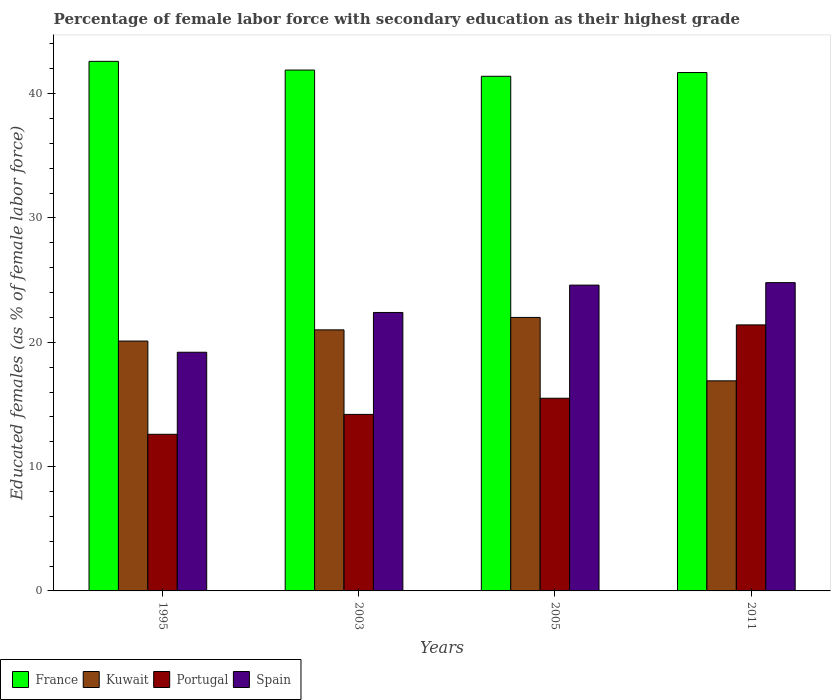How many different coloured bars are there?
Your answer should be very brief. 4. How many groups of bars are there?
Your answer should be compact. 4. What is the percentage of female labor force with secondary education in Spain in 2003?
Your answer should be compact. 22.4. Across all years, what is the maximum percentage of female labor force with secondary education in Kuwait?
Offer a very short reply. 22. Across all years, what is the minimum percentage of female labor force with secondary education in Portugal?
Your answer should be compact. 12.6. In which year was the percentage of female labor force with secondary education in Spain minimum?
Keep it short and to the point. 1995. What is the total percentage of female labor force with secondary education in Spain in the graph?
Keep it short and to the point. 91. What is the difference between the percentage of female labor force with secondary education in Portugal in 1995 and that in 2003?
Keep it short and to the point. -1.6. What is the difference between the percentage of female labor force with secondary education in France in 2011 and the percentage of female labor force with secondary education in Kuwait in 2003?
Make the answer very short. 20.7. In the year 2005, what is the difference between the percentage of female labor force with secondary education in Kuwait and percentage of female labor force with secondary education in Portugal?
Give a very brief answer. 6.5. What is the ratio of the percentage of female labor force with secondary education in Portugal in 1995 to that in 2003?
Offer a very short reply. 0.89. Is the percentage of female labor force with secondary education in Portugal in 2003 less than that in 2005?
Give a very brief answer. Yes. What is the difference between the highest and the lowest percentage of female labor force with secondary education in Kuwait?
Your answer should be very brief. 5.1. Is the sum of the percentage of female labor force with secondary education in France in 1995 and 2003 greater than the maximum percentage of female labor force with secondary education in Spain across all years?
Make the answer very short. Yes. What does the 2nd bar from the left in 2003 represents?
Your answer should be compact. Kuwait. What does the 1st bar from the right in 2003 represents?
Give a very brief answer. Spain. Is it the case that in every year, the sum of the percentage of female labor force with secondary education in Kuwait and percentage of female labor force with secondary education in France is greater than the percentage of female labor force with secondary education in Portugal?
Provide a succinct answer. Yes. Are all the bars in the graph horizontal?
Your response must be concise. No. How many years are there in the graph?
Give a very brief answer. 4. Does the graph contain any zero values?
Provide a succinct answer. No. Does the graph contain grids?
Keep it short and to the point. No. How many legend labels are there?
Ensure brevity in your answer.  4. What is the title of the graph?
Your answer should be very brief. Percentage of female labor force with secondary education as their highest grade. What is the label or title of the Y-axis?
Offer a terse response. Educated females (as % of female labor force). What is the Educated females (as % of female labor force) of France in 1995?
Provide a succinct answer. 42.6. What is the Educated females (as % of female labor force) of Kuwait in 1995?
Provide a short and direct response. 20.1. What is the Educated females (as % of female labor force) in Portugal in 1995?
Keep it short and to the point. 12.6. What is the Educated females (as % of female labor force) in Spain in 1995?
Your answer should be very brief. 19.2. What is the Educated females (as % of female labor force) of France in 2003?
Your response must be concise. 41.9. What is the Educated females (as % of female labor force) in Portugal in 2003?
Keep it short and to the point. 14.2. What is the Educated females (as % of female labor force) in Spain in 2003?
Provide a short and direct response. 22.4. What is the Educated females (as % of female labor force) of France in 2005?
Provide a succinct answer. 41.4. What is the Educated females (as % of female labor force) of Kuwait in 2005?
Make the answer very short. 22. What is the Educated females (as % of female labor force) of Spain in 2005?
Give a very brief answer. 24.6. What is the Educated females (as % of female labor force) in France in 2011?
Offer a terse response. 41.7. What is the Educated females (as % of female labor force) of Kuwait in 2011?
Provide a short and direct response. 16.9. What is the Educated females (as % of female labor force) in Portugal in 2011?
Your answer should be compact. 21.4. What is the Educated females (as % of female labor force) of Spain in 2011?
Your answer should be compact. 24.8. Across all years, what is the maximum Educated females (as % of female labor force) in France?
Make the answer very short. 42.6. Across all years, what is the maximum Educated females (as % of female labor force) in Portugal?
Your answer should be very brief. 21.4. Across all years, what is the maximum Educated females (as % of female labor force) in Spain?
Your answer should be compact. 24.8. Across all years, what is the minimum Educated females (as % of female labor force) of France?
Your answer should be very brief. 41.4. Across all years, what is the minimum Educated females (as % of female labor force) in Kuwait?
Provide a succinct answer. 16.9. Across all years, what is the minimum Educated females (as % of female labor force) in Portugal?
Offer a very short reply. 12.6. Across all years, what is the minimum Educated females (as % of female labor force) in Spain?
Your answer should be very brief. 19.2. What is the total Educated females (as % of female labor force) in France in the graph?
Your response must be concise. 167.6. What is the total Educated females (as % of female labor force) of Kuwait in the graph?
Your response must be concise. 80. What is the total Educated females (as % of female labor force) in Portugal in the graph?
Offer a very short reply. 63.7. What is the total Educated females (as % of female labor force) in Spain in the graph?
Your response must be concise. 91. What is the difference between the Educated females (as % of female labor force) in Kuwait in 1995 and that in 2003?
Your response must be concise. -0.9. What is the difference between the Educated females (as % of female labor force) in Kuwait in 1995 and that in 2011?
Your answer should be compact. 3.2. What is the difference between the Educated females (as % of female labor force) of Portugal in 1995 and that in 2011?
Offer a terse response. -8.8. What is the difference between the Educated females (as % of female labor force) in Portugal in 2003 and that in 2005?
Give a very brief answer. -1.3. What is the difference between the Educated females (as % of female labor force) of France in 2003 and that in 2011?
Provide a short and direct response. 0.2. What is the difference between the Educated females (as % of female labor force) in Portugal in 2003 and that in 2011?
Give a very brief answer. -7.2. What is the difference between the Educated females (as % of female labor force) of Kuwait in 2005 and that in 2011?
Provide a short and direct response. 5.1. What is the difference between the Educated females (as % of female labor force) of Portugal in 2005 and that in 2011?
Ensure brevity in your answer.  -5.9. What is the difference between the Educated females (as % of female labor force) of Spain in 2005 and that in 2011?
Your answer should be compact. -0.2. What is the difference between the Educated females (as % of female labor force) of France in 1995 and the Educated females (as % of female labor force) of Kuwait in 2003?
Provide a succinct answer. 21.6. What is the difference between the Educated females (as % of female labor force) in France in 1995 and the Educated females (as % of female labor force) in Portugal in 2003?
Your answer should be compact. 28.4. What is the difference between the Educated females (as % of female labor force) in France in 1995 and the Educated females (as % of female labor force) in Spain in 2003?
Ensure brevity in your answer.  20.2. What is the difference between the Educated females (as % of female labor force) in Kuwait in 1995 and the Educated females (as % of female labor force) in Spain in 2003?
Keep it short and to the point. -2.3. What is the difference between the Educated females (as % of female labor force) in France in 1995 and the Educated females (as % of female labor force) in Kuwait in 2005?
Provide a succinct answer. 20.6. What is the difference between the Educated females (as % of female labor force) in France in 1995 and the Educated females (as % of female labor force) in Portugal in 2005?
Keep it short and to the point. 27.1. What is the difference between the Educated females (as % of female labor force) of Kuwait in 1995 and the Educated females (as % of female labor force) of Portugal in 2005?
Offer a terse response. 4.6. What is the difference between the Educated females (as % of female labor force) of Portugal in 1995 and the Educated females (as % of female labor force) of Spain in 2005?
Offer a very short reply. -12. What is the difference between the Educated females (as % of female labor force) of France in 1995 and the Educated females (as % of female labor force) of Kuwait in 2011?
Offer a terse response. 25.7. What is the difference between the Educated females (as % of female labor force) in France in 1995 and the Educated females (as % of female labor force) in Portugal in 2011?
Provide a succinct answer. 21.2. What is the difference between the Educated females (as % of female labor force) in Kuwait in 1995 and the Educated females (as % of female labor force) in Portugal in 2011?
Your answer should be compact. -1.3. What is the difference between the Educated females (as % of female labor force) in Kuwait in 1995 and the Educated females (as % of female labor force) in Spain in 2011?
Give a very brief answer. -4.7. What is the difference between the Educated females (as % of female labor force) of Portugal in 1995 and the Educated females (as % of female labor force) of Spain in 2011?
Provide a short and direct response. -12.2. What is the difference between the Educated females (as % of female labor force) in France in 2003 and the Educated females (as % of female labor force) in Kuwait in 2005?
Your answer should be very brief. 19.9. What is the difference between the Educated females (as % of female labor force) in France in 2003 and the Educated females (as % of female labor force) in Portugal in 2005?
Keep it short and to the point. 26.4. What is the difference between the Educated females (as % of female labor force) of France in 2003 and the Educated females (as % of female labor force) of Spain in 2005?
Your response must be concise. 17.3. What is the difference between the Educated females (as % of female labor force) in Kuwait in 2003 and the Educated females (as % of female labor force) in Portugal in 2005?
Your response must be concise. 5.5. What is the difference between the Educated females (as % of female labor force) of Kuwait in 2003 and the Educated females (as % of female labor force) of Spain in 2005?
Your response must be concise. -3.6. What is the difference between the Educated females (as % of female labor force) of France in 2003 and the Educated females (as % of female labor force) of Kuwait in 2011?
Your answer should be very brief. 25. What is the difference between the Educated females (as % of female labor force) of France in 2003 and the Educated females (as % of female labor force) of Portugal in 2011?
Provide a short and direct response. 20.5. What is the difference between the Educated females (as % of female labor force) of Portugal in 2003 and the Educated females (as % of female labor force) of Spain in 2011?
Your answer should be compact. -10.6. What is the difference between the Educated females (as % of female labor force) in France in 2005 and the Educated females (as % of female labor force) in Kuwait in 2011?
Provide a succinct answer. 24.5. What is the difference between the Educated females (as % of female labor force) of France in 2005 and the Educated females (as % of female labor force) of Portugal in 2011?
Make the answer very short. 20. What is the difference between the Educated females (as % of female labor force) in Kuwait in 2005 and the Educated females (as % of female labor force) in Portugal in 2011?
Give a very brief answer. 0.6. What is the difference between the Educated females (as % of female labor force) of Kuwait in 2005 and the Educated females (as % of female labor force) of Spain in 2011?
Make the answer very short. -2.8. What is the average Educated females (as % of female labor force) in France per year?
Offer a terse response. 41.9. What is the average Educated females (as % of female labor force) of Portugal per year?
Provide a short and direct response. 15.93. What is the average Educated females (as % of female labor force) in Spain per year?
Offer a terse response. 22.75. In the year 1995, what is the difference between the Educated females (as % of female labor force) of France and Educated females (as % of female labor force) of Portugal?
Offer a terse response. 30. In the year 1995, what is the difference between the Educated females (as % of female labor force) of France and Educated females (as % of female labor force) of Spain?
Provide a succinct answer. 23.4. In the year 2003, what is the difference between the Educated females (as % of female labor force) in France and Educated females (as % of female labor force) in Kuwait?
Ensure brevity in your answer.  20.9. In the year 2003, what is the difference between the Educated females (as % of female labor force) in France and Educated females (as % of female labor force) in Portugal?
Keep it short and to the point. 27.7. In the year 2003, what is the difference between the Educated females (as % of female labor force) in France and Educated females (as % of female labor force) in Spain?
Your response must be concise. 19.5. In the year 2003, what is the difference between the Educated females (as % of female labor force) of Kuwait and Educated females (as % of female labor force) of Spain?
Your answer should be compact. -1.4. In the year 2003, what is the difference between the Educated females (as % of female labor force) in Portugal and Educated females (as % of female labor force) in Spain?
Provide a succinct answer. -8.2. In the year 2005, what is the difference between the Educated females (as % of female labor force) of France and Educated females (as % of female labor force) of Portugal?
Make the answer very short. 25.9. In the year 2005, what is the difference between the Educated females (as % of female labor force) in Kuwait and Educated females (as % of female labor force) in Portugal?
Your response must be concise. 6.5. In the year 2005, what is the difference between the Educated females (as % of female labor force) of Portugal and Educated females (as % of female labor force) of Spain?
Offer a terse response. -9.1. In the year 2011, what is the difference between the Educated females (as % of female labor force) in France and Educated females (as % of female labor force) in Kuwait?
Offer a terse response. 24.8. In the year 2011, what is the difference between the Educated females (as % of female labor force) in France and Educated females (as % of female labor force) in Portugal?
Make the answer very short. 20.3. In the year 2011, what is the difference between the Educated females (as % of female labor force) of Kuwait and Educated females (as % of female labor force) of Portugal?
Give a very brief answer. -4.5. In the year 2011, what is the difference between the Educated females (as % of female labor force) of Kuwait and Educated females (as % of female labor force) of Spain?
Offer a very short reply. -7.9. In the year 2011, what is the difference between the Educated females (as % of female labor force) of Portugal and Educated females (as % of female labor force) of Spain?
Ensure brevity in your answer.  -3.4. What is the ratio of the Educated females (as % of female labor force) of France in 1995 to that in 2003?
Keep it short and to the point. 1.02. What is the ratio of the Educated females (as % of female labor force) in Kuwait in 1995 to that in 2003?
Provide a short and direct response. 0.96. What is the ratio of the Educated females (as % of female labor force) of Portugal in 1995 to that in 2003?
Your answer should be very brief. 0.89. What is the ratio of the Educated females (as % of female labor force) of Spain in 1995 to that in 2003?
Provide a short and direct response. 0.86. What is the ratio of the Educated females (as % of female labor force) of France in 1995 to that in 2005?
Make the answer very short. 1.03. What is the ratio of the Educated females (as % of female labor force) of Kuwait in 1995 to that in 2005?
Give a very brief answer. 0.91. What is the ratio of the Educated females (as % of female labor force) of Portugal in 1995 to that in 2005?
Make the answer very short. 0.81. What is the ratio of the Educated females (as % of female labor force) in Spain in 1995 to that in 2005?
Provide a short and direct response. 0.78. What is the ratio of the Educated females (as % of female labor force) of France in 1995 to that in 2011?
Give a very brief answer. 1.02. What is the ratio of the Educated females (as % of female labor force) of Kuwait in 1995 to that in 2011?
Offer a very short reply. 1.19. What is the ratio of the Educated females (as % of female labor force) of Portugal in 1995 to that in 2011?
Your response must be concise. 0.59. What is the ratio of the Educated females (as % of female labor force) of Spain in 1995 to that in 2011?
Keep it short and to the point. 0.77. What is the ratio of the Educated females (as % of female labor force) of France in 2003 to that in 2005?
Provide a succinct answer. 1.01. What is the ratio of the Educated females (as % of female labor force) of Kuwait in 2003 to that in 2005?
Keep it short and to the point. 0.95. What is the ratio of the Educated females (as % of female labor force) of Portugal in 2003 to that in 2005?
Keep it short and to the point. 0.92. What is the ratio of the Educated females (as % of female labor force) of Spain in 2003 to that in 2005?
Provide a short and direct response. 0.91. What is the ratio of the Educated females (as % of female labor force) in France in 2003 to that in 2011?
Your answer should be very brief. 1. What is the ratio of the Educated females (as % of female labor force) of Kuwait in 2003 to that in 2011?
Offer a very short reply. 1.24. What is the ratio of the Educated females (as % of female labor force) in Portugal in 2003 to that in 2011?
Your answer should be very brief. 0.66. What is the ratio of the Educated females (as % of female labor force) in Spain in 2003 to that in 2011?
Offer a very short reply. 0.9. What is the ratio of the Educated females (as % of female labor force) in France in 2005 to that in 2011?
Provide a short and direct response. 0.99. What is the ratio of the Educated females (as % of female labor force) in Kuwait in 2005 to that in 2011?
Your response must be concise. 1.3. What is the ratio of the Educated females (as % of female labor force) in Portugal in 2005 to that in 2011?
Your response must be concise. 0.72. What is the ratio of the Educated females (as % of female labor force) in Spain in 2005 to that in 2011?
Your response must be concise. 0.99. What is the difference between the highest and the second highest Educated females (as % of female labor force) of France?
Offer a terse response. 0.7. What is the difference between the highest and the second highest Educated females (as % of female labor force) in Kuwait?
Your response must be concise. 1. What is the difference between the highest and the lowest Educated females (as % of female labor force) of France?
Keep it short and to the point. 1.2. 